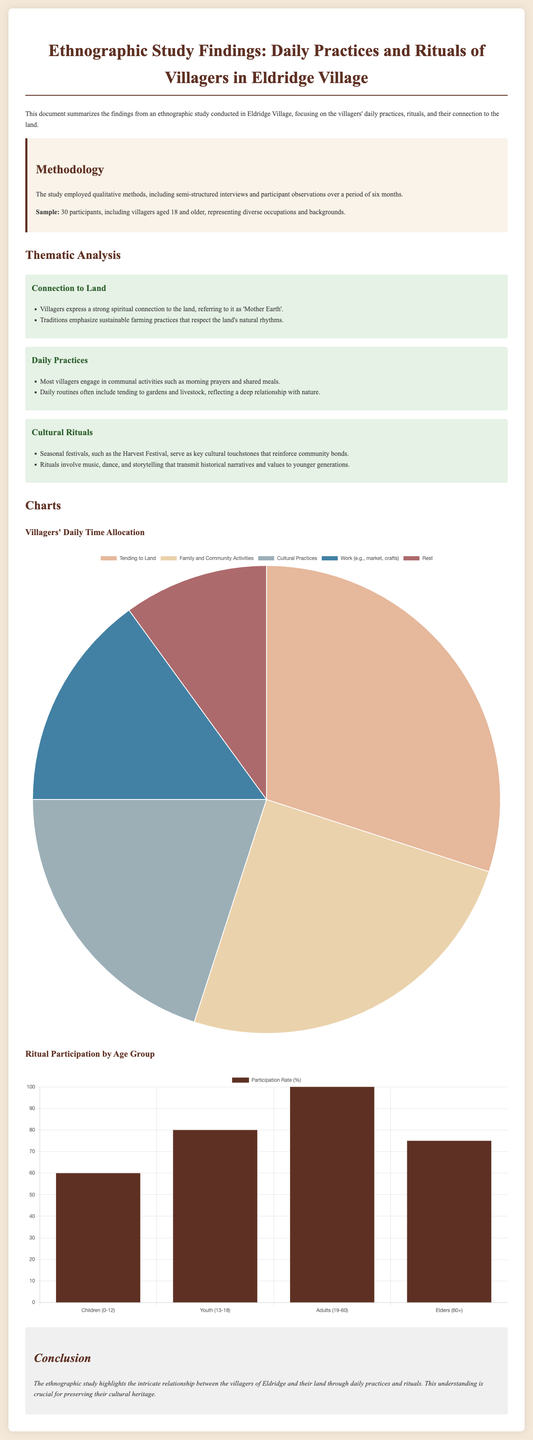What is the title of the document? The title of the document is presented at the top of the page.
Answer: Ethnographic Study Findings: Daily Practices and Rituals of Villagers in Eldridge Village How many participants were involved in the study? The number of participants in the study is mentioned in the methodology section.
Answer: 30 participants What does "Mother Earth" refer to in the document? "Mother Earth" is described in the context of the villagers' spiritual connection to the land.
Answer: The land What is the highest participation rate in rituals by age group? The participation rates by age group are listed in the ritual participation chart.
Answer: 100 Which daily activity occupies the largest percentage of time according to the chart? The daily time allocation chart shows the different activities and their respective allocations.
Answer: Tending to Land What seasonal festival is mentioned in the study? The cultural rituals section references a specific festival as a cultural touchstone.
Answer: Harvest Festival What is the primary methodology used in the study? The methods employed for the study are outlined in the methodology section.
Answer: Qualitative methods What percentage of time is allocated to cultural practices? The daily time allocation chart provides a breakdown of time spent on various activities.
Answer: 20 What is the focus of the ethnographic study? The focus is stated in the introductory paragraph of the document.
Answer: Villagers' daily practices, rituals, and their connection to the land 